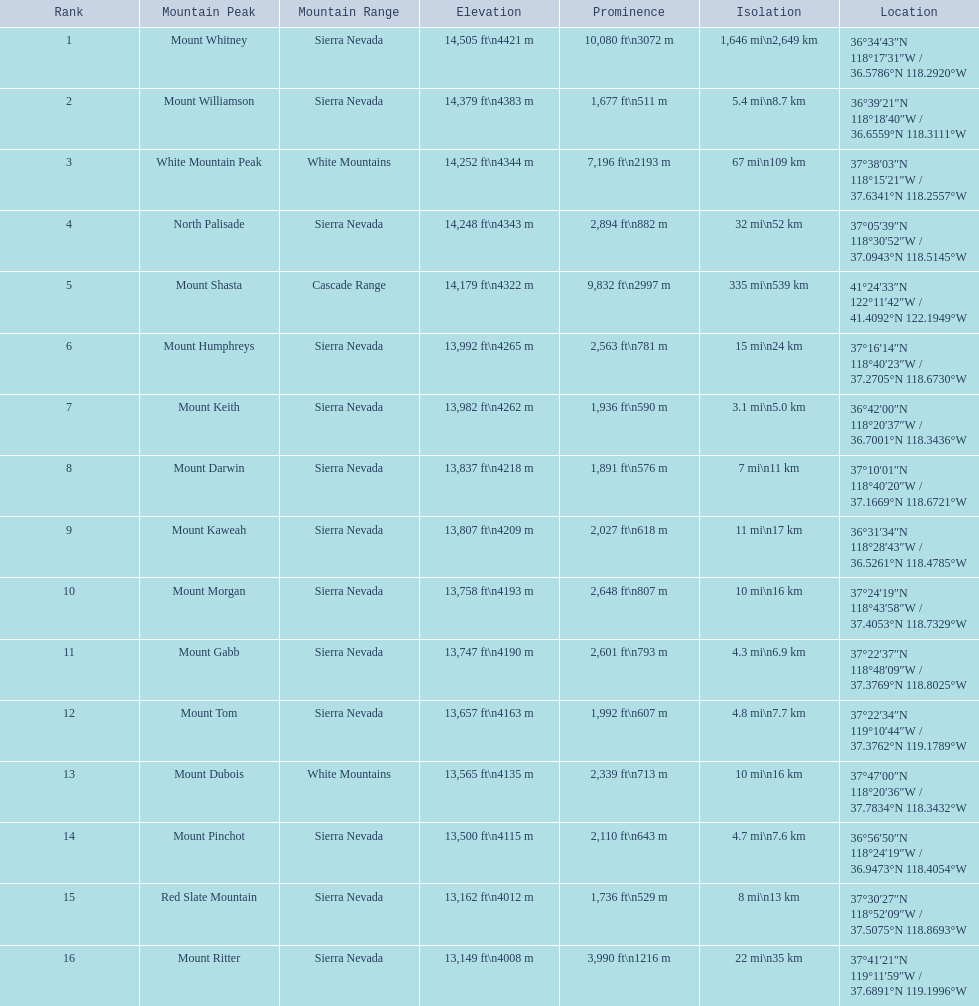What are the altitudes of the mountain tops? 14,505 ft\n4421 m, 14,379 ft\n4383 m, 14,252 ft\n4344 m, 14,248 ft\n4343 m, 14,179 ft\n4322 m, 13,992 ft\n4265 m, 13,982 ft\n4262 m, 13,837 ft\n4218 m, 13,807 ft\n4209 m, 13,758 ft\n4193 m, 13,747 ft\n4190 m, 13,657 ft\n4163 m, 13,565 ft\n4135 m, 13,500 ft\n4115 m, 13,162 ft\n4012 m, 13,149 ft\n4008 m. Which of these altitudes is the loftiest? 14,505 ft\n4421 m. What mountain top is 14,505 feet? Mount Whitney. 